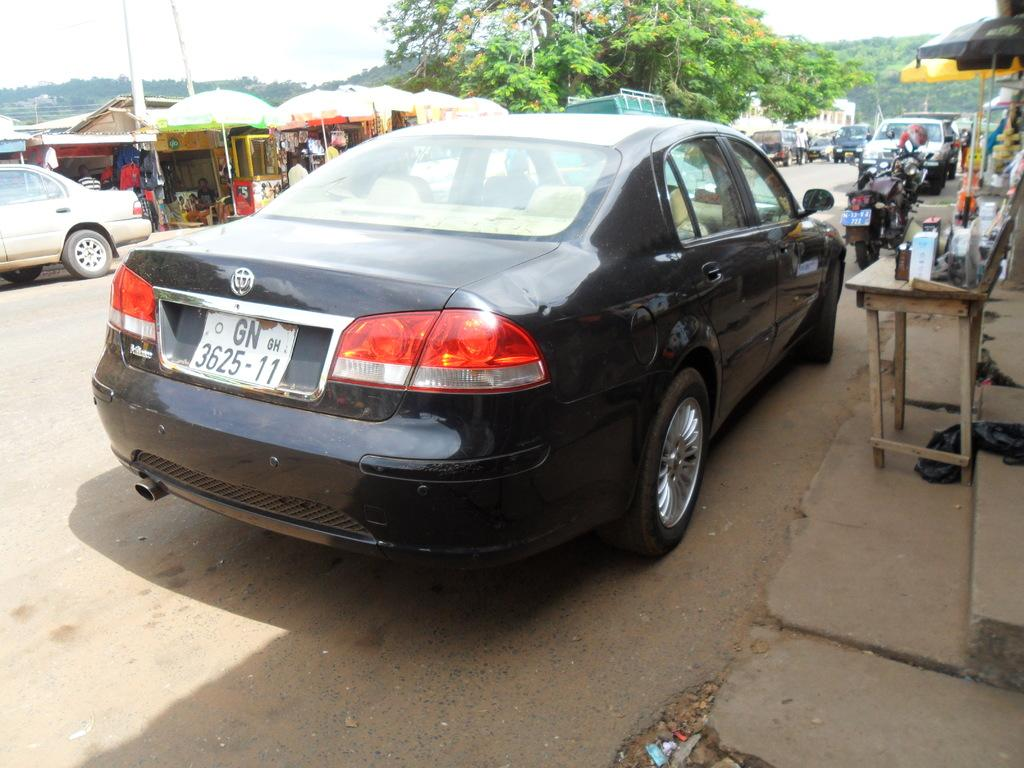What is the main subject of the image? The main subject of the image is a car. Where is the car located in the image? The car is parked on the road in the image. What other vehicles can be seen in the area? There are bikes in the area. What type of natural elements are present in the image? There are trees in the area. What is the condition of the news in the image? There is no news present in the image; it features a car parked on the road with bikes and trees in the area. 